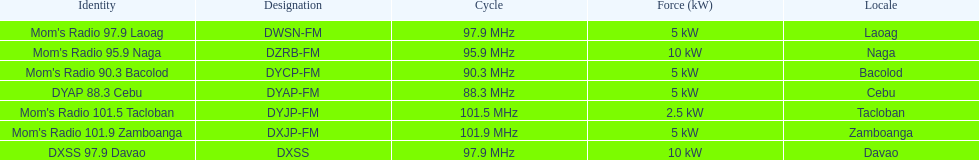How many times is the frequency greater than 95? 5. Can you parse all the data within this table? {'header': ['Identity', 'Designation', 'Cycle', 'Force (kW)', 'Locale'], 'rows': [["Mom's Radio 97.9 Laoag", 'DWSN-FM', '97.9\xa0MHz', '5\xa0kW', 'Laoag'], ["Mom's Radio 95.9 Naga", 'DZRB-FM', '95.9\xa0MHz', '10\xa0kW', 'Naga'], ["Mom's Radio 90.3 Bacolod", 'DYCP-FM', '90.3\xa0MHz', '5\xa0kW', 'Bacolod'], ['DYAP 88.3 Cebu', 'DYAP-FM', '88.3\xa0MHz', '5\xa0kW', 'Cebu'], ["Mom's Radio 101.5 Tacloban", 'DYJP-FM', '101.5\xa0MHz', '2.5\xa0kW', 'Tacloban'], ["Mom's Radio 101.9 Zamboanga", 'DXJP-FM', '101.9\xa0MHz', '5\xa0kW', 'Zamboanga'], ['DXSS 97.9 Davao', 'DXSS', '97.9\xa0MHz', '10\xa0kW', 'Davao']]} 